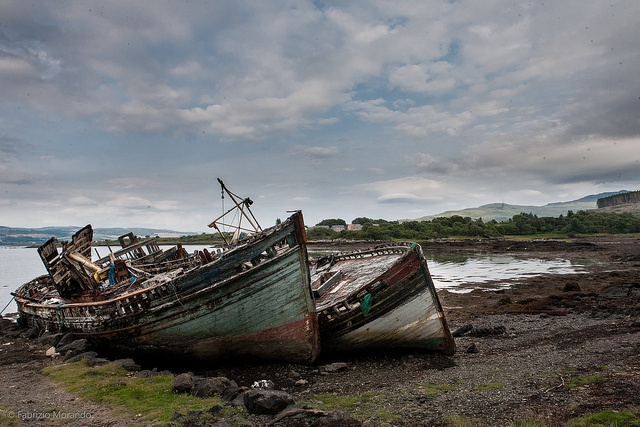Describe the objects in this image and their specific colors. I can see boat in gray, black, maroon, and darkgray tones and boat in gray, black, and darkgray tones in this image. 